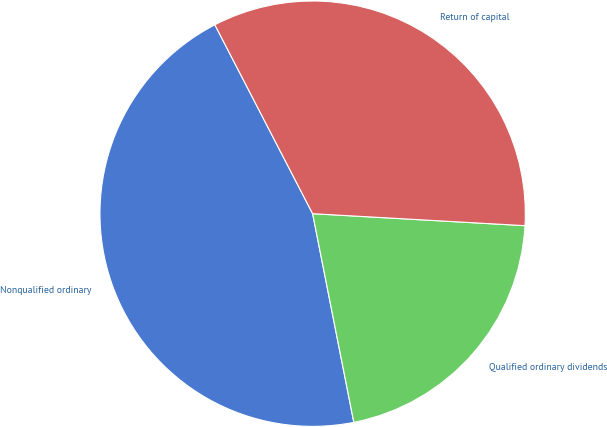Convert chart. <chart><loc_0><loc_0><loc_500><loc_500><pie_chart><fcel>Nonqualified ordinary<fcel>Qualified ordinary dividends<fcel>Return of capital<nl><fcel>45.5%<fcel>21.0%<fcel>33.5%<nl></chart> 